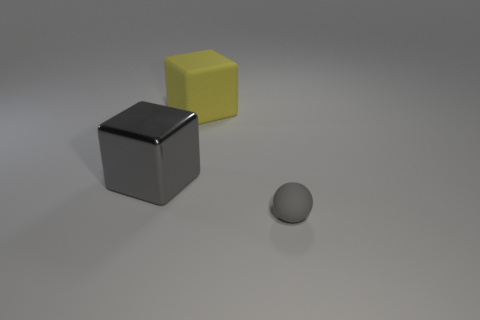Add 1 big green cubes. How many objects exist? 4 Subtract all cubes. How many objects are left? 1 Subtract 0 blue cubes. How many objects are left? 3 Subtract all small things. Subtract all blocks. How many objects are left? 0 Add 1 large rubber things. How many large rubber things are left? 2 Add 1 blocks. How many blocks exist? 3 